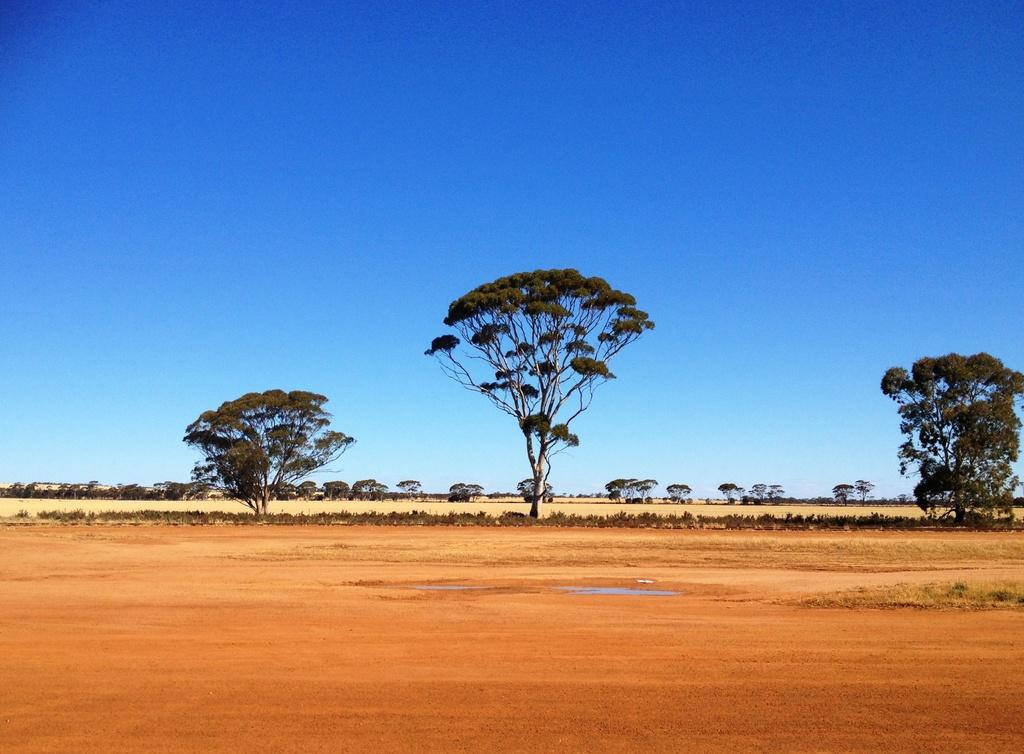What type of surface can be seen in the image? There is ground visible in the image. What type of vegetation is present in the image? There are plants, grass, and trees in the image. What part of the natural environment is visible in the image? The sky is visible in the background of the image. How long does it take for the plants to start learning in the image? Plants do not have the ability to learn, so this question cannot be answered. 